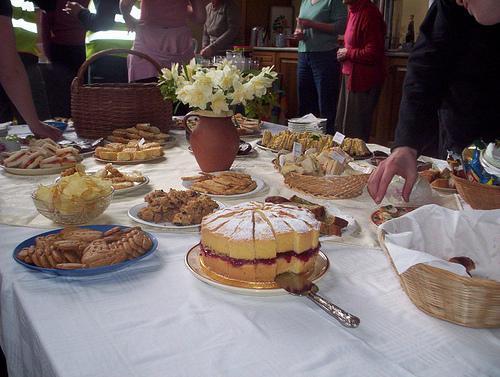How many people are in the picture?
Give a very brief answer. 6. How many elephants are standing on two legs?
Give a very brief answer. 0. 